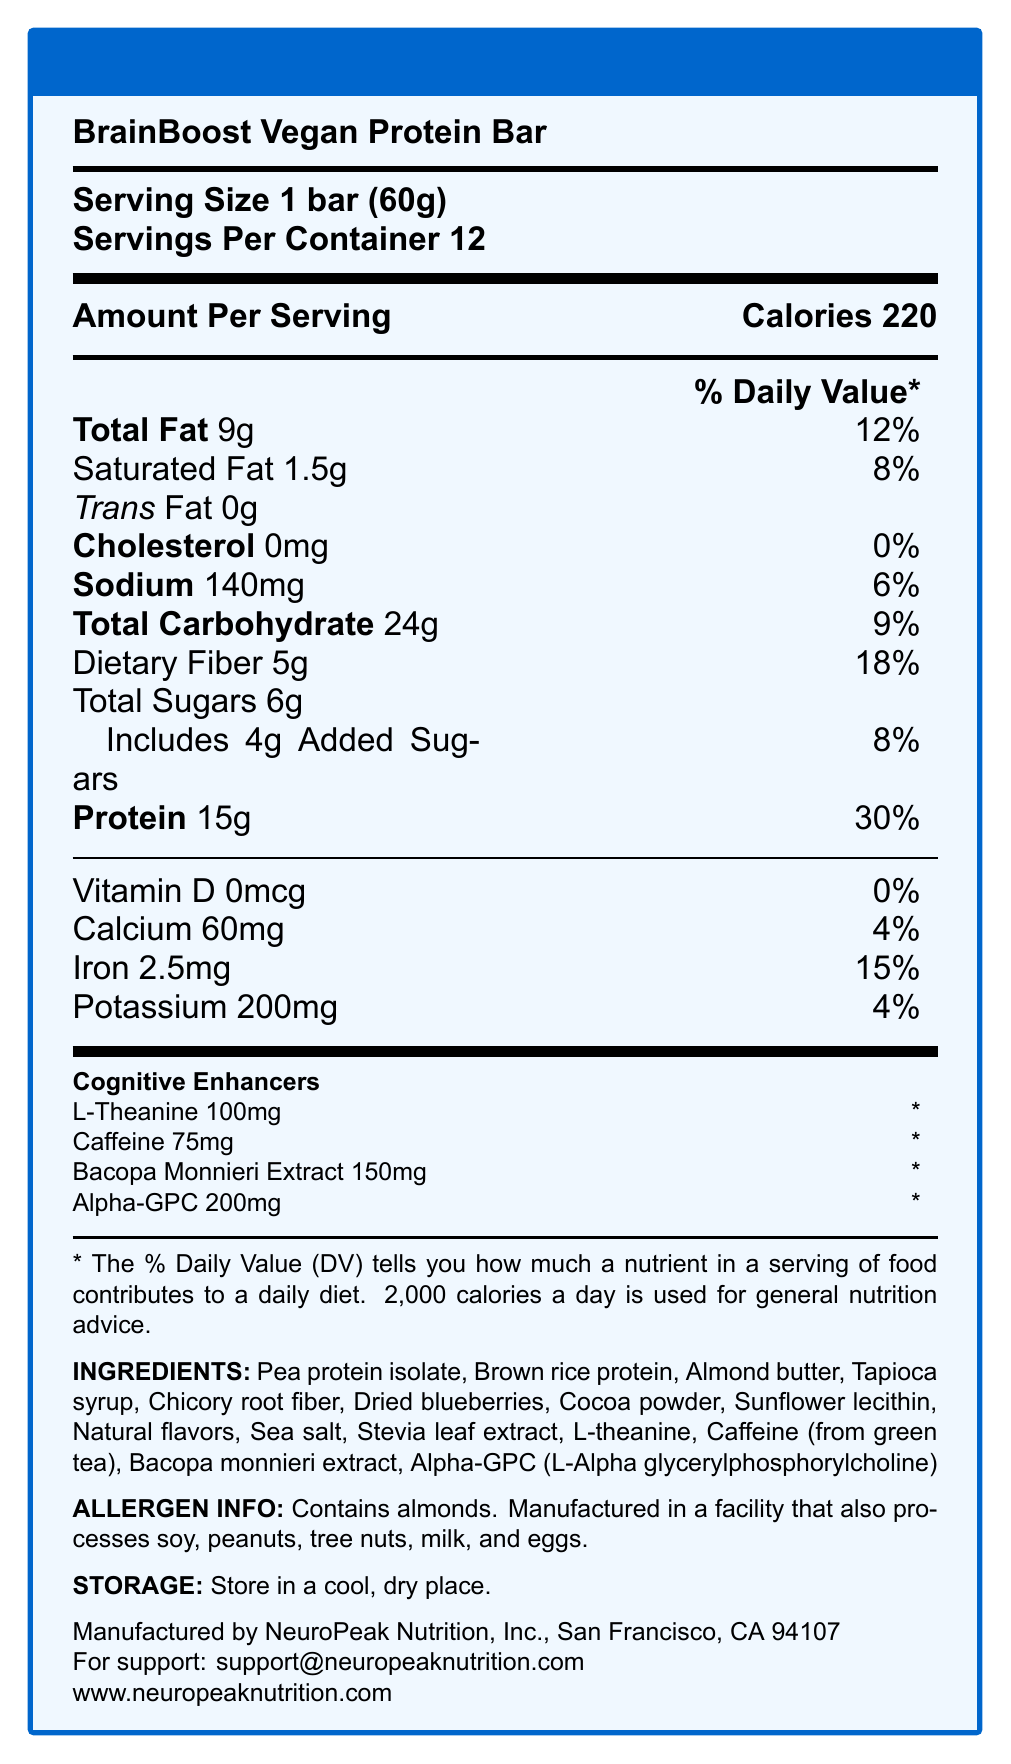what is the serving size? The serving size is stated directly under the product name as "Serving Size 1 bar (60g)".
Answer: 1 bar (60g) how many servings are in a container? The document specifies "Servings Per Container" as 12.
Answer: 12 how many calories are there in a single serving? The amount per serving states "Calories 220" next to the title "Amount Per Serving".
Answer: 220 what is the amount of added sugars per serving? The nutrition facts list "Includes 4g Added Sugars" under Total Sugars.
Answer: 4g what is the percentage of the Daily Value for protein? Under the nutrition details for protein, it indicates "Protein 15g & 30%".
Answer: 30% what are the main cognitive enhancers included in the bar? A. Caffeine, Bacopa Monnieri, Omega-3 B. L-Theanine, Caffeine, Bacopa Monnieri, Alpha-GPC C. L-Theanine, Vitamin D, Iron, Tryptophan The section on Cognitive Enhancers lists L-Theanine, Caffeine, Bacopa Monnieri Extract, and Alpha-GPC.
Answer: B which vitamins and minerals are included in the bar? A. Vitamin D, Calcium, Iron, Potassium B. Vitamin A, Vitamin C, Calcium, Magnesium C. Vitamin E, Vitamin B6, Zinc, Calcium The vitamins and minerals section lists Vitamin D, Calcium, Iron, and Potassium.
Answer: A is this bar suitable for individuals with peanut allergies? The allergen information states that the bar contains almonds and is manufactured in a facility that processes peanuts.
Answer: No does the protein bar contain any cholesterol? The nutrition facts under cholesterol state "Cholesterol 0mg & 0%".
Answer: No summarize the main features and nutritional content of the BrainBoost Vegan Protein Bar. This summary captures the key nutritional points, cognitive enhancers, allergens, and ingredients from the document.
Answer: The BrainBoost Vegan Protein Bar has 220 calories per serving, with 15g of protein, 24g of carbohydrates (including 5g of dietary fiber and 4g of added sugars), and 9g of total fat. It contains cognitive enhancers like L-Theanine, Caffeine, Bacopa Monnieri Extract, and Alpha-GPC. It is made from ingredients like pea protein isolate and almond butter and contains almonds. what is the total daily value percentage of iron per serving? The amount of iron per serving is listed as 2.5mg, which is 15% of the Daily Value.
Answer: 15% which ingredient derived from green tea does the bar contain? The ingredient list notes "Caffeine (from green tea)".
Answer: Caffeine how much L-Theanine is in each bar? The amount of L-Theanine per serving is listed in the Cognitive Enhancers section.
Answer: 100mg how many grams of dietary fiber are in each serving? A. 2g B. 5g C. 9g D. 15g The nutrition facts state "Dietary Fiber 5g & 18%".
Answer: B is there any information about whether the product contains gluten? The document does not provide specific information regarding the presence or absence of gluten.
Answer: Not enough information what are the recommended storage instructions? The storage instructions state "Store in a cool, dry place." under the allergen info.
Answer: Store in a cool, dry place. 